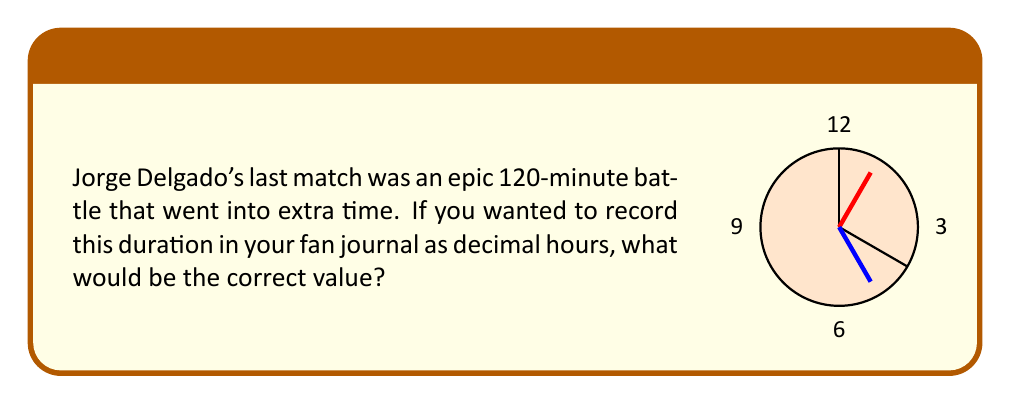What is the answer to this math problem? To convert the match duration from minutes to decimal hours, we need to follow these steps:

1) First, let's set up the conversion ratio:
   $1 \text{ hour} = 60 \text{ minutes}$

2) We can express this as a fraction:
   $\frac{1 \text{ hour}}{60 \text{ minutes}}$

3) Now, we can set up a proportion to convert 120 minutes to hours:
   $\frac{x \text{ hours}}{120 \text{ minutes}} = \frac{1 \text{ hour}}{60 \text{ minutes}}$

4) Cross multiply:
   $60x = 120$

5) Solve for x:
   $x = \frac{120}{60} = 2$

Therefore, 120 minutes is equal to 2 decimal hours.
Answer: 2 hours 